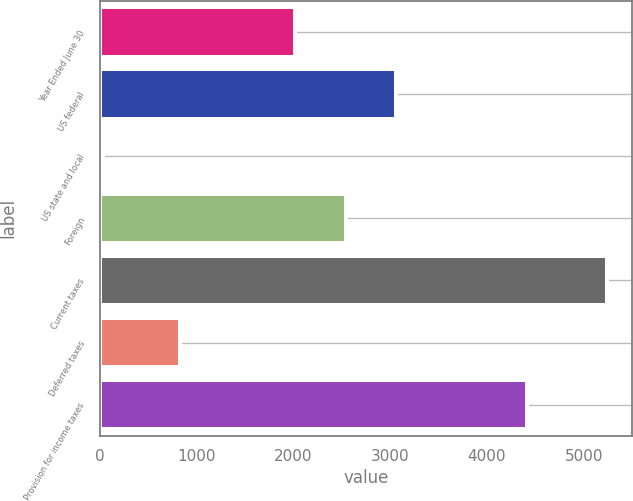<chart> <loc_0><loc_0><loc_500><loc_500><bar_chart><fcel>Year Ended June 30<fcel>US federal<fcel>US state and local<fcel>Foreign<fcel>Current taxes<fcel>Deferred taxes<fcel>Provision for income taxes<nl><fcel>2017<fcel>3059.2<fcel>30<fcel>2538.1<fcel>5241<fcel>829<fcel>4412<nl></chart> 